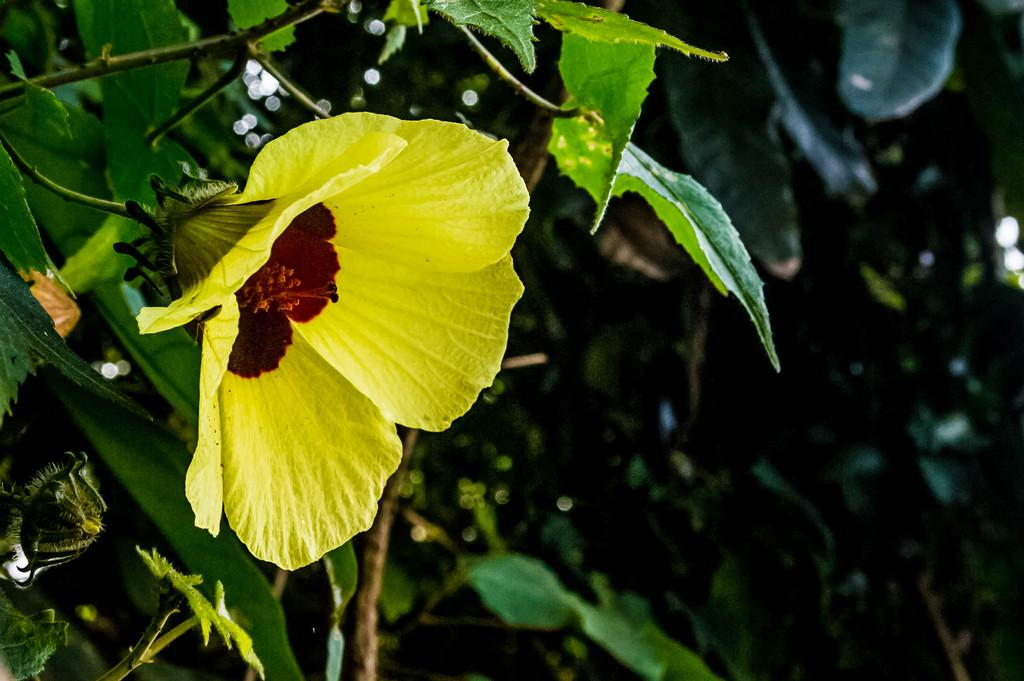What is the main subject of the image? There is a plant in the image. What specific features can be observed on the plant? The plant has a flower and a bud. What can be seen in the background of the image? There are other plants in the background of the image. How can the background plants be described? The background plants have leaves. What type of rock is being used as a glove by the plant in the image? There is no rock or glove present in the image; it features a plant with a flower and a bud. Can you tell me the color of the badge on the plant in the image? There is no badge present on the plant in the image. 